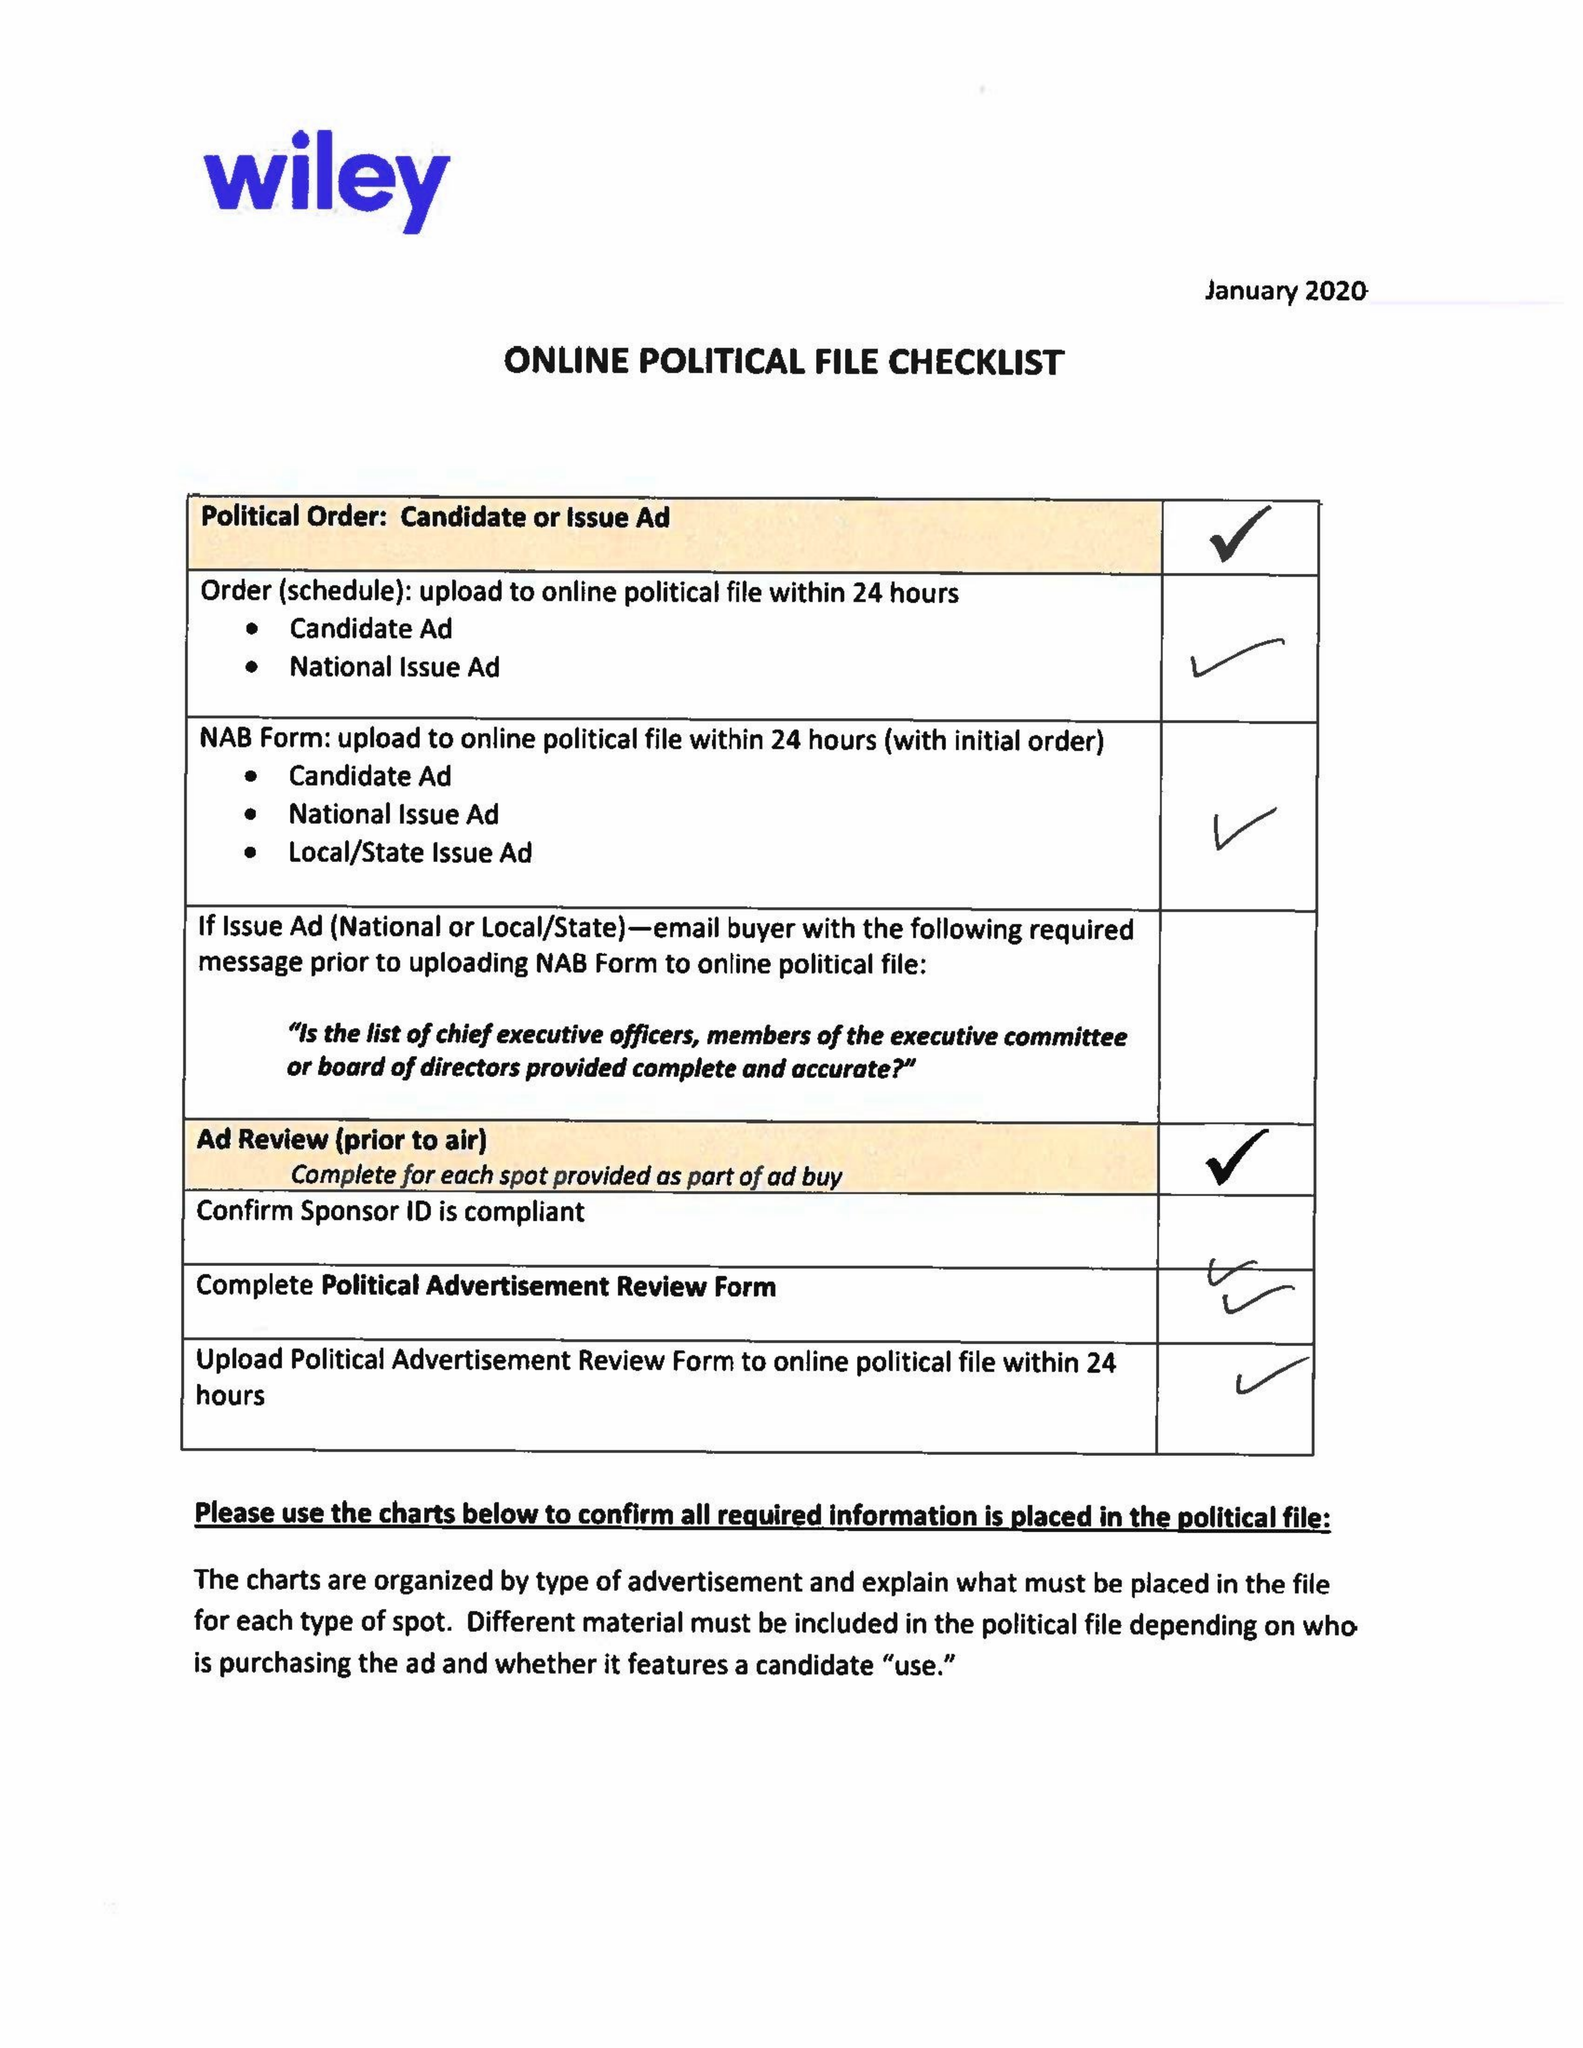What is the value for the contract_num?
Answer the question using a single word or phrase. 1515498 